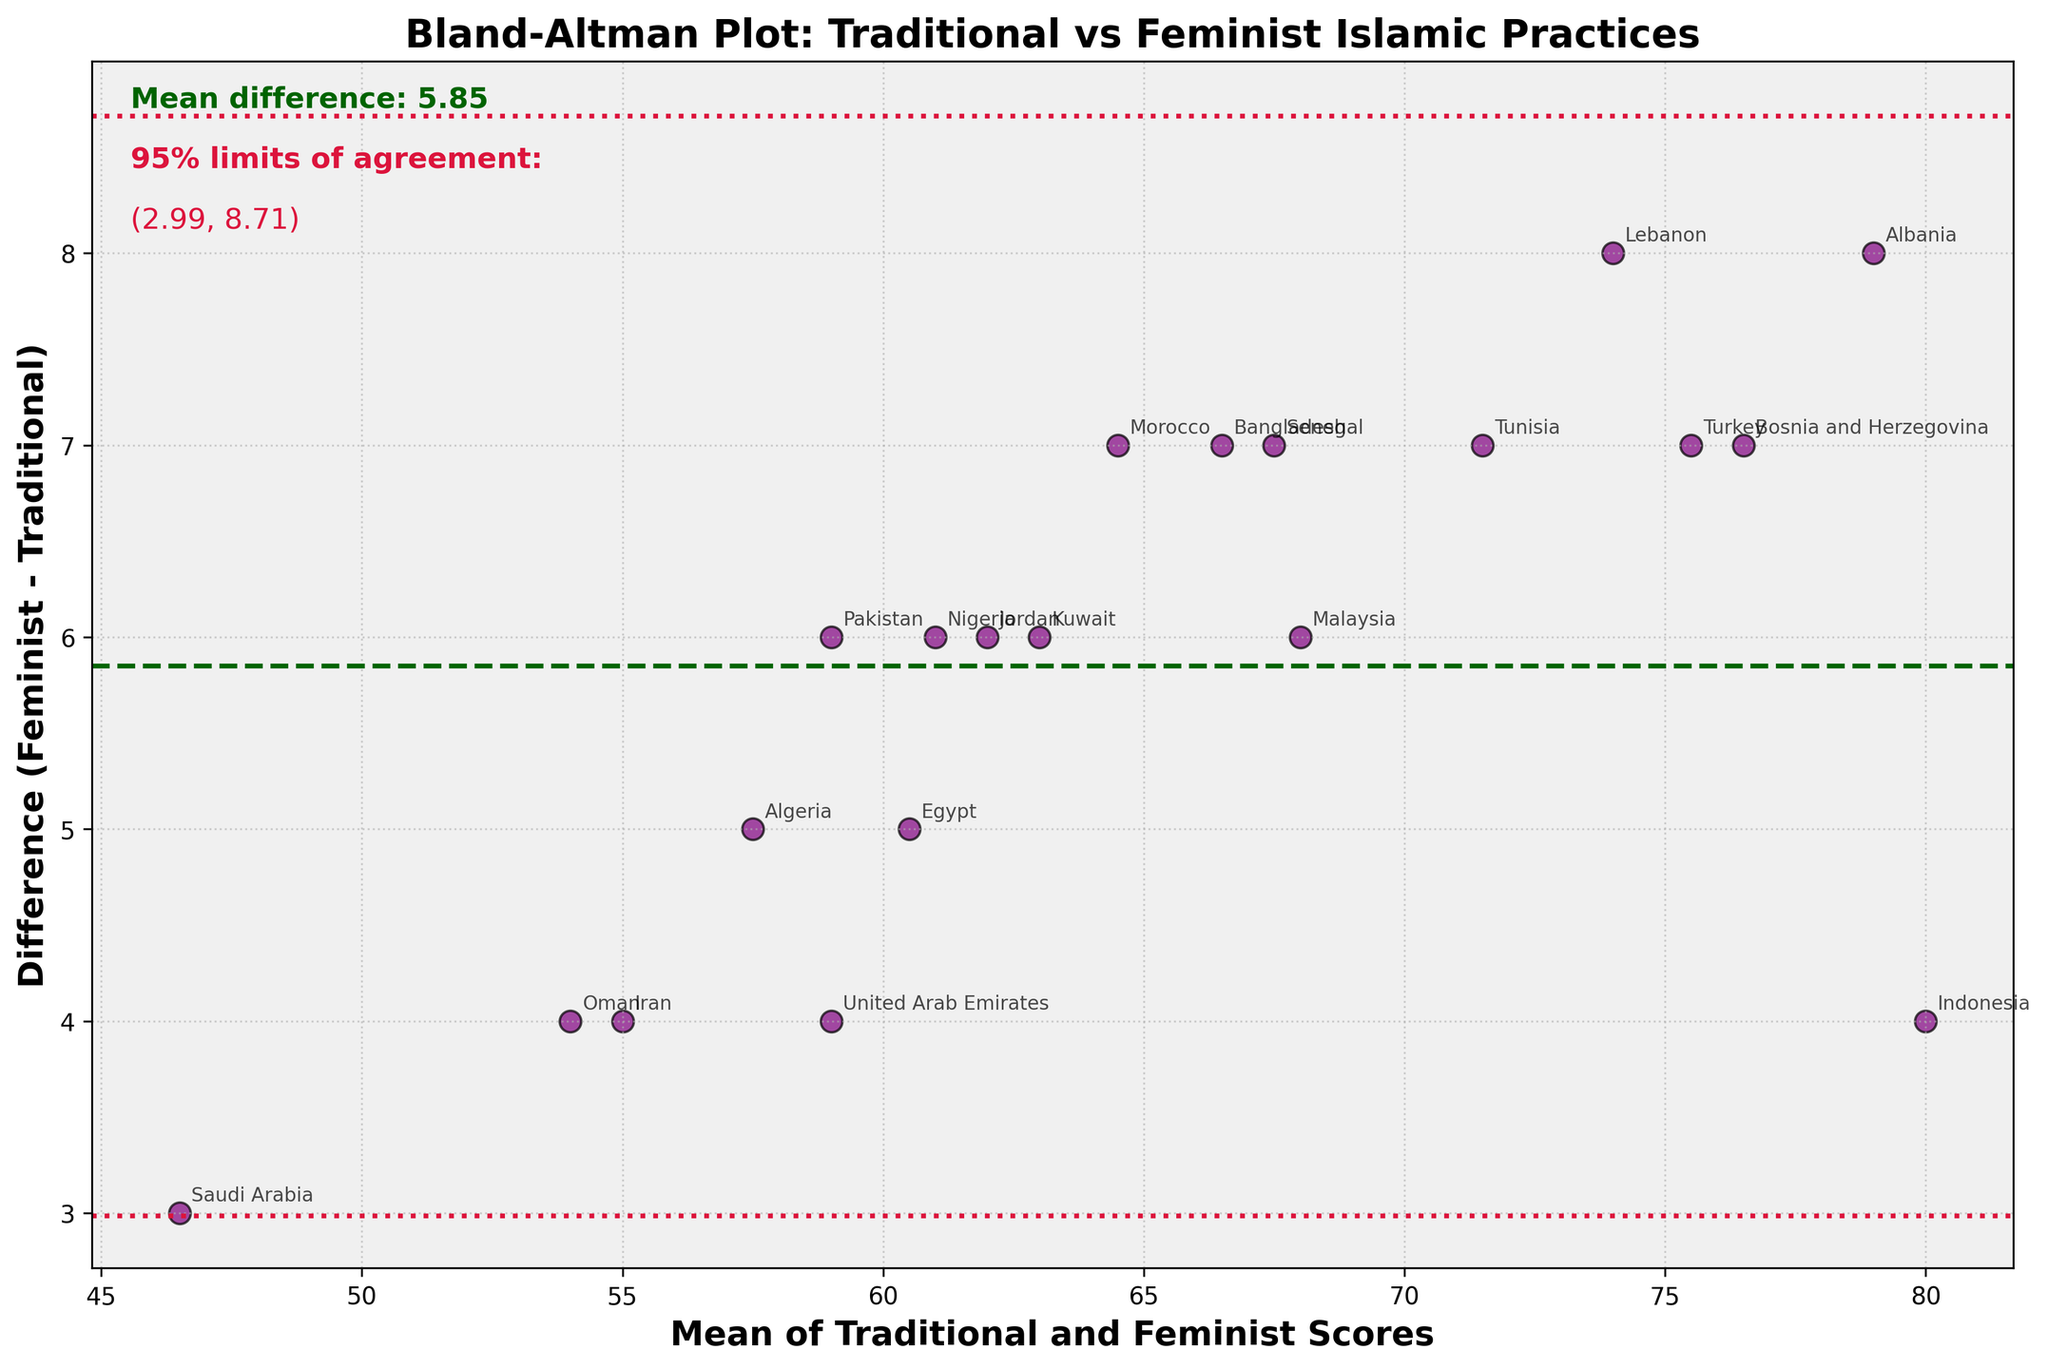What is the title of the Bland-Altman plot? The title is displayed at the top of the figure and it reads, "Bland-Altman Plot: Traditional vs Feminist Islamic Practices".
Answer: Bland-Altman Plot: Traditional vs Feminist Islamic Practices How many countries are represented in the plot? Each data point on the Bland-Altman plot represents a country. By counting the data points, you can determine the number of countries.
Answer: 20 What is the mean difference between the feminist and traditional practice scores? The mean difference is indicated by a horizontal dashed green line, and it is also labelled on the figure.
Answer: 6.00 Which country has the highest positive difference between feminist and traditional practice scores? The data point with the highest position on the y-axis represents the highest positive difference. By annotating the point, you can see it represents Albania.
Answer: Albania What are the 95% limits of agreement for the differences in scores? These limits are represented by the dotted red lines on the plot and are also annotated in the plot. They range from (2.20, 9.80).
Answer: 2.20 to 9.80 Which country has a mean score closest to 70 and what is its corresponding difference? Find the data point closest to 70 on the x-axis (mean score), which is Lebanon. The corresponding difference can be observed from the y-axis value for this point.
Answer: Lebanon, 8 Compare the mean scores and difference values of Turkey and Jordan. Which has a higher difference value? Locate Turkey and Jordan on the plot. Turkey has a higher mean score and a higher difference value based on their positions on the y-axis and x-axis.
Answer: Turkey What color are the data points and what other visual elements differentiate them in the plot? The data points are represented in purple, with black edges around each marker to distinguish them.
Answer: Purple with black edges What is the average of the mean scores of Indonesia and Turkey? Locate Indonesia and Turkey, observe their mean scores (80 and 75.5, respectively), and calculate their average. (82 + 75.5) / 2 = 78.75
Answer: 78.75 How many countries have a mean score above 65 but below 75? Look at the x-axis (mean of traditional and feminist scores) and count the data points falling in the range between 65 and 75.
Answer: 6 